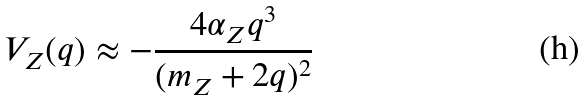<formula> <loc_0><loc_0><loc_500><loc_500>V _ { Z } ( q ) \approx - \frac { 4 \alpha _ { Z } q ^ { 3 } } { ( m _ { Z } + 2 q ) ^ { 2 } }</formula> 